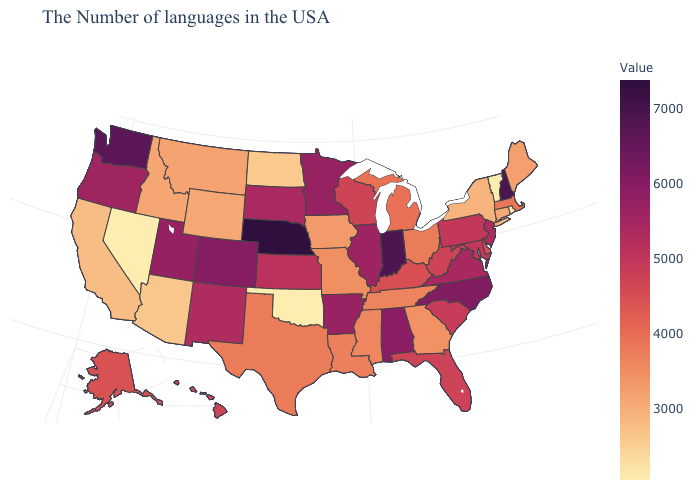Does Idaho have a lower value than New Jersey?
Answer briefly. Yes. Which states have the highest value in the USA?
Give a very brief answer. Nebraska. Which states have the highest value in the USA?
Short answer required. Nebraska. Among the states that border Oklahoma , does Colorado have the highest value?
Answer briefly. Yes. 